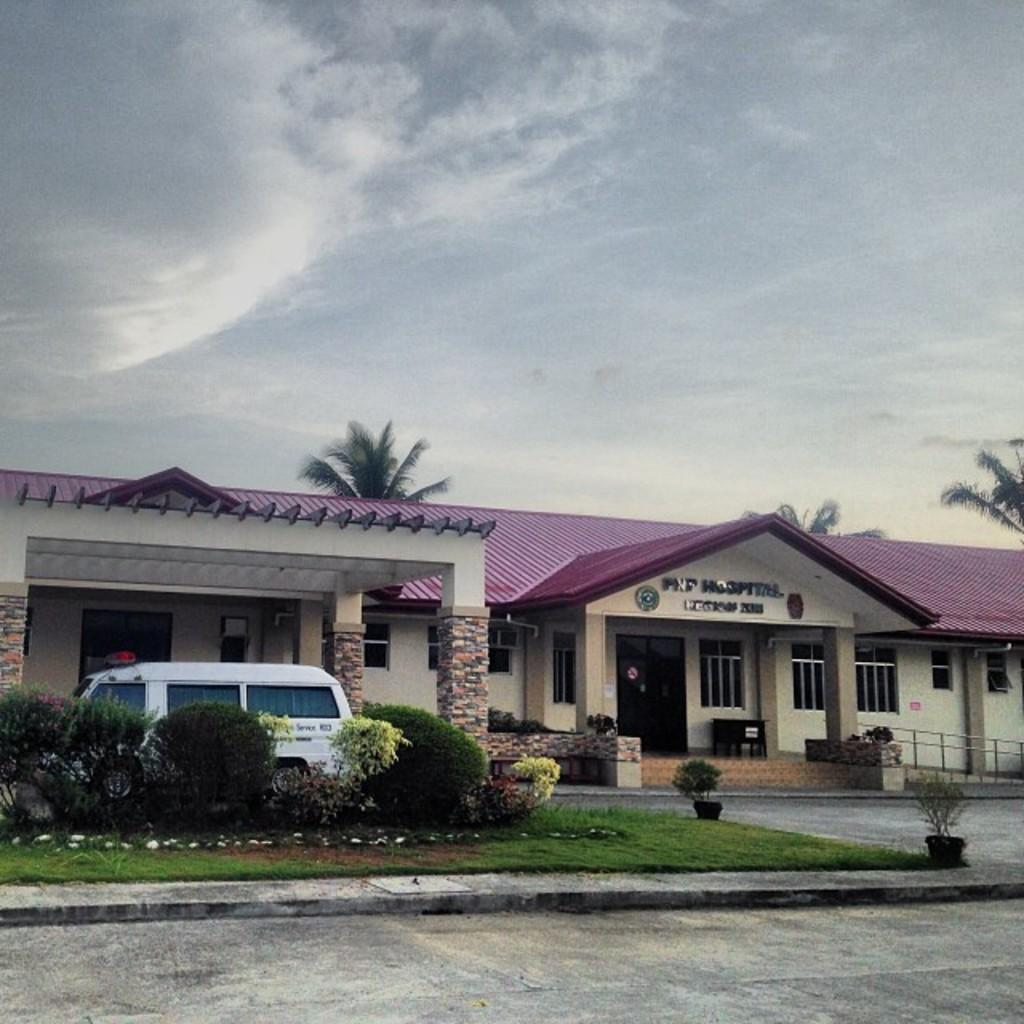What can be seen in the middle of the image? In the middle of the image, there are trees, a building, a planter, a vehicle, grass, a flower pot, text, and a railing. What type of surface is visible at the bottom of the image? There is a road at the bottom of the image. What is visible at the top of the image? The sky is visible at the top of the image. How many apples are being used as a weapon in the war depicted in the image? There is no depiction of a war or apples being used as weapons in the image. What type of butter is being spread on the toast in the image? There is no toast or butter present in the image. 